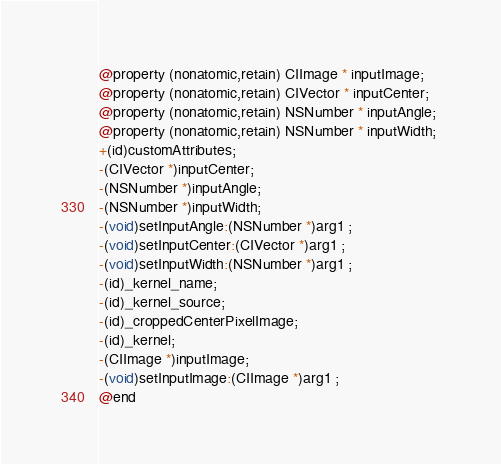Convert code to text. <code><loc_0><loc_0><loc_500><loc_500><_C_>
@property (nonatomic,retain) CIImage * inputImage; 
@property (nonatomic,retain) CIVector * inputCenter; 
@property (nonatomic,retain) NSNumber * inputAngle; 
@property (nonatomic,retain) NSNumber * inputWidth; 
+(id)customAttributes;
-(CIVector *)inputCenter;
-(NSNumber *)inputAngle;
-(NSNumber *)inputWidth;
-(void)setInputAngle:(NSNumber *)arg1 ;
-(void)setInputCenter:(CIVector *)arg1 ;
-(void)setInputWidth:(NSNumber *)arg1 ;
-(id)_kernel_name;
-(id)_kernel_source;
-(id)_croppedCenterPixelImage;
-(id)_kernel;
-(CIImage *)inputImage;
-(void)setInputImage:(CIImage *)arg1 ;
@end

</code> 